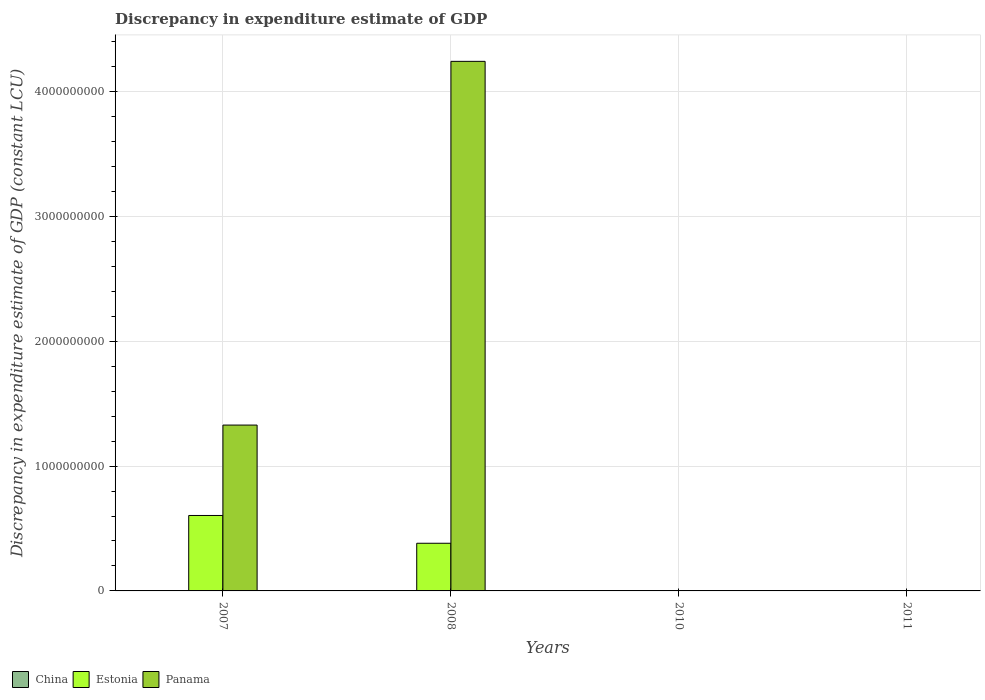Are the number of bars per tick equal to the number of legend labels?
Offer a very short reply. No. How many bars are there on the 1st tick from the left?
Keep it short and to the point. 2. How many bars are there on the 3rd tick from the right?
Ensure brevity in your answer.  2. In how many cases, is the number of bars for a given year not equal to the number of legend labels?
Your answer should be very brief. 4. What is the discrepancy in expenditure estimate of GDP in Estonia in 2007?
Give a very brief answer. 6.04e+08. Across all years, what is the maximum discrepancy in expenditure estimate of GDP in Estonia?
Your response must be concise. 6.04e+08. Across all years, what is the minimum discrepancy in expenditure estimate of GDP in Panama?
Make the answer very short. 0. In which year was the discrepancy in expenditure estimate of GDP in Panama maximum?
Provide a short and direct response. 2008. What is the total discrepancy in expenditure estimate of GDP in Panama in the graph?
Your response must be concise. 5.57e+09. What is the difference between the discrepancy in expenditure estimate of GDP in Estonia in 2007 and that in 2008?
Ensure brevity in your answer.  2.23e+08. What is the difference between the discrepancy in expenditure estimate of GDP in Estonia in 2008 and the discrepancy in expenditure estimate of GDP in China in 2011?
Your answer should be compact. 3.82e+08. What is the average discrepancy in expenditure estimate of GDP in Panama per year?
Make the answer very short. 1.39e+09. In the year 2007, what is the difference between the discrepancy in expenditure estimate of GDP in Estonia and discrepancy in expenditure estimate of GDP in Panama?
Provide a short and direct response. -7.24e+08. In how many years, is the discrepancy in expenditure estimate of GDP in China greater than 3800000000 LCU?
Provide a succinct answer. 0. Is the discrepancy in expenditure estimate of GDP in Panama in 2007 less than that in 2008?
Your response must be concise. Yes. What is the difference between the highest and the second highest discrepancy in expenditure estimate of GDP in Panama?
Provide a short and direct response. 2.91e+09. What is the difference between the highest and the lowest discrepancy in expenditure estimate of GDP in Estonia?
Your response must be concise. 6.04e+08. Are all the bars in the graph horizontal?
Make the answer very short. No. What is the difference between two consecutive major ticks on the Y-axis?
Give a very brief answer. 1.00e+09. Does the graph contain any zero values?
Make the answer very short. Yes. Does the graph contain grids?
Give a very brief answer. Yes. How many legend labels are there?
Give a very brief answer. 3. How are the legend labels stacked?
Provide a succinct answer. Horizontal. What is the title of the graph?
Keep it short and to the point. Discrepancy in expenditure estimate of GDP. Does "Lao PDR" appear as one of the legend labels in the graph?
Give a very brief answer. No. What is the label or title of the Y-axis?
Offer a terse response. Discrepancy in expenditure estimate of GDP (constant LCU). What is the Discrepancy in expenditure estimate of GDP (constant LCU) in China in 2007?
Your response must be concise. 0. What is the Discrepancy in expenditure estimate of GDP (constant LCU) of Estonia in 2007?
Make the answer very short. 6.04e+08. What is the Discrepancy in expenditure estimate of GDP (constant LCU) in Panama in 2007?
Provide a succinct answer. 1.33e+09. What is the Discrepancy in expenditure estimate of GDP (constant LCU) of China in 2008?
Keep it short and to the point. 0. What is the Discrepancy in expenditure estimate of GDP (constant LCU) of Estonia in 2008?
Ensure brevity in your answer.  3.82e+08. What is the Discrepancy in expenditure estimate of GDP (constant LCU) in Panama in 2008?
Offer a very short reply. 4.24e+09. What is the Discrepancy in expenditure estimate of GDP (constant LCU) in Estonia in 2010?
Give a very brief answer. 2.97e+06. What is the Discrepancy in expenditure estimate of GDP (constant LCU) in China in 2011?
Provide a short and direct response. 0. Across all years, what is the maximum Discrepancy in expenditure estimate of GDP (constant LCU) of Estonia?
Your answer should be compact. 6.04e+08. Across all years, what is the maximum Discrepancy in expenditure estimate of GDP (constant LCU) of Panama?
Offer a terse response. 4.24e+09. Across all years, what is the minimum Discrepancy in expenditure estimate of GDP (constant LCU) of Estonia?
Your response must be concise. 0. Across all years, what is the minimum Discrepancy in expenditure estimate of GDP (constant LCU) of Panama?
Provide a succinct answer. 0. What is the total Discrepancy in expenditure estimate of GDP (constant LCU) in Estonia in the graph?
Keep it short and to the point. 9.89e+08. What is the total Discrepancy in expenditure estimate of GDP (constant LCU) of Panama in the graph?
Provide a succinct answer. 5.57e+09. What is the difference between the Discrepancy in expenditure estimate of GDP (constant LCU) in Estonia in 2007 and that in 2008?
Keep it short and to the point. 2.23e+08. What is the difference between the Discrepancy in expenditure estimate of GDP (constant LCU) in Panama in 2007 and that in 2008?
Keep it short and to the point. -2.91e+09. What is the difference between the Discrepancy in expenditure estimate of GDP (constant LCU) in Estonia in 2007 and that in 2010?
Offer a very short reply. 6.01e+08. What is the difference between the Discrepancy in expenditure estimate of GDP (constant LCU) of Panama in 2007 and that in 2011?
Your response must be concise. 1.33e+09. What is the difference between the Discrepancy in expenditure estimate of GDP (constant LCU) in Estonia in 2008 and that in 2010?
Give a very brief answer. 3.79e+08. What is the difference between the Discrepancy in expenditure estimate of GDP (constant LCU) in Panama in 2008 and that in 2011?
Your response must be concise. 4.24e+09. What is the difference between the Discrepancy in expenditure estimate of GDP (constant LCU) of Estonia in 2007 and the Discrepancy in expenditure estimate of GDP (constant LCU) of Panama in 2008?
Give a very brief answer. -3.64e+09. What is the difference between the Discrepancy in expenditure estimate of GDP (constant LCU) of Estonia in 2007 and the Discrepancy in expenditure estimate of GDP (constant LCU) of Panama in 2011?
Make the answer very short. 6.04e+08. What is the difference between the Discrepancy in expenditure estimate of GDP (constant LCU) in Estonia in 2008 and the Discrepancy in expenditure estimate of GDP (constant LCU) in Panama in 2011?
Your answer should be very brief. 3.82e+08. What is the difference between the Discrepancy in expenditure estimate of GDP (constant LCU) of Estonia in 2010 and the Discrepancy in expenditure estimate of GDP (constant LCU) of Panama in 2011?
Give a very brief answer. 2.97e+06. What is the average Discrepancy in expenditure estimate of GDP (constant LCU) of Estonia per year?
Provide a succinct answer. 2.47e+08. What is the average Discrepancy in expenditure estimate of GDP (constant LCU) in Panama per year?
Your answer should be compact. 1.39e+09. In the year 2007, what is the difference between the Discrepancy in expenditure estimate of GDP (constant LCU) of Estonia and Discrepancy in expenditure estimate of GDP (constant LCU) of Panama?
Keep it short and to the point. -7.24e+08. In the year 2008, what is the difference between the Discrepancy in expenditure estimate of GDP (constant LCU) of Estonia and Discrepancy in expenditure estimate of GDP (constant LCU) of Panama?
Offer a very short reply. -3.86e+09. What is the ratio of the Discrepancy in expenditure estimate of GDP (constant LCU) of Estonia in 2007 to that in 2008?
Keep it short and to the point. 1.58. What is the ratio of the Discrepancy in expenditure estimate of GDP (constant LCU) in Panama in 2007 to that in 2008?
Provide a succinct answer. 0.31. What is the ratio of the Discrepancy in expenditure estimate of GDP (constant LCU) in Estonia in 2007 to that in 2010?
Keep it short and to the point. 203.45. What is the ratio of the Discrepancy in expenditure estimate of GDP (constant LCU) in Panama in 2007 to that in 2011?
Your answer should be very brief. 1.33e+07. What is the ratio of the Discrepancy in expenditure estimate of GDP (constant LCU) of Estonia in 2008 to that in 2010?
Your response must be concise. 128.53. What is the ratio of the Discrepancy in expenditure estimate of GDP (constant LCU) in Panama in 2008 to that in 2011?
Offer a very short reply. 4.24e+07. What is the difference between the highest and the second highest Discrepancy in expenditure estimate of GDP (constant LCU) of Estonia?
Your response must be concise. 2.23e+08. What is the difference between the highest and the second highest Discrepancy in expenditure estimate of GDP (constant LCU) of Panama?
Provide a short and direct response. 2.91e+09. What is the difference between the highest and the lowest Discrepancy in expenditure estimate of GDP (constant LCU) of Estonia?
Ensure brevity in your answer.  6.04e+08. What is the difference between the highest and the lowest Discrepancy in expenditure estimate of GDP (constant LCU) in Panama?
Your response must be concise. 4.24e+09. 